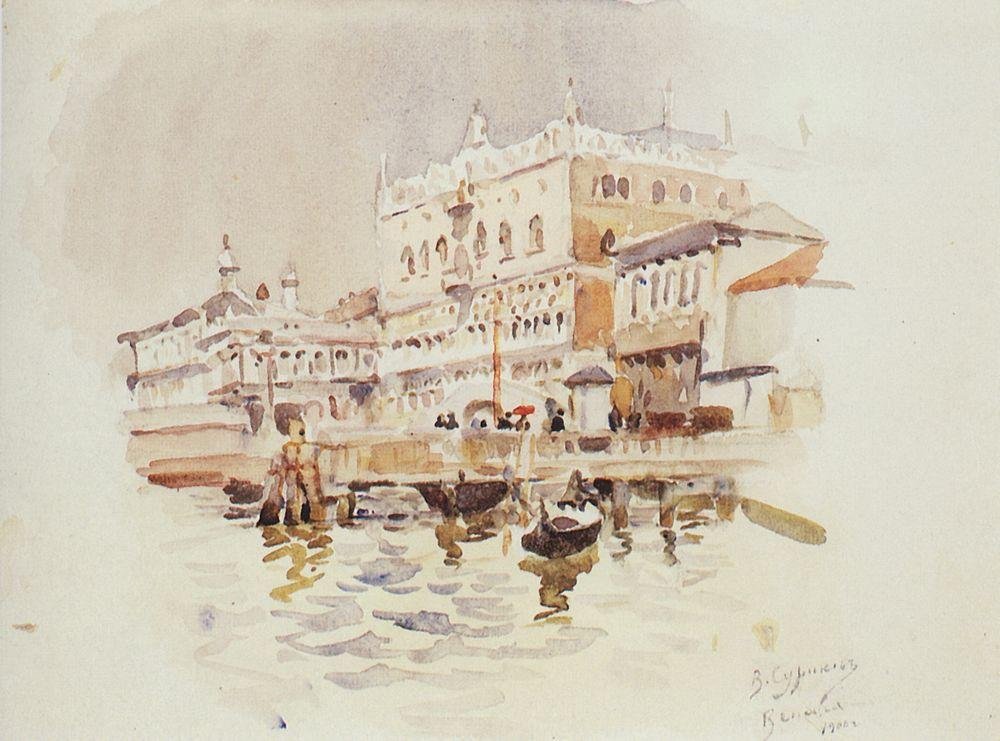What do you think is going on in this snapshot? The painting captures a picturesque scene from Venice, showcasing a grand palace along the Grand Canal. The palace, with its white façade and red roof, stands out prominently against the serene blue waters of the canal. The architecture is richly detailed, epitomizing the ornate style for which Venice is famous. Multiple boats are seen in the foreground, hinting at the lively activity on the canal. Painted in an impressionistic style, the artwork emphasizes light, color, and atmosphere over fine detail. Notably, the artist's signature 'B. S. Haines' is present, along with a note 'R. M. W. Turner Venice', indicating the inspiration drawn from the renowned artist Turner. The overall ambiance suggests a busy yet timeless Venetian scene, with a focus on daily life and architectural beauty. 